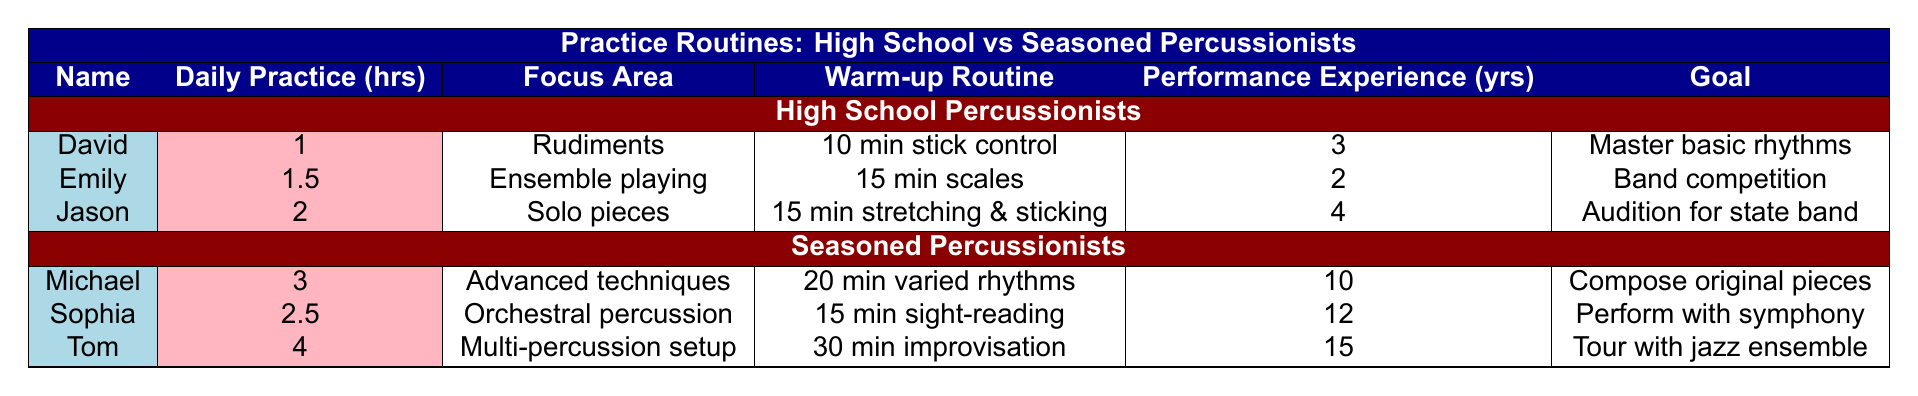What is the maximum number of daily practice hours among high school percussionists? The table shows three high school percussionists: David (1 hr), Emily (1.5 hrs), and Jason (2 hrs). The maximum value among these is Jason's 2 hrs.
Answer: 2 hrs Which seasoned percussionist has the highest performance experience? From the table, we see that Tom has 15 years of performance experience, which is greater than Michael's 10 and Sophia's 12 years.
Answer: Tom What is the warm-up routine for Jason? According to the table, Jason's warm-up routine consists of "5 minutes of stretching, 10 minutes of basic sticking patterns."
Answer: 5 minutes of stretching, 10 minutes of basic sticking patterns How many more hours do seasoned percussionists practice daily on average compared to high school percussionists? High school percussionists have practice hours of 1, 1.5, and 2, which totals 4.5 hours divided by 3 gives an average of 1.5 hours. Seasoned percussionists have 3, 2.5, and 4, totaling 9.5 hours, which gives an average of about 3.17 hours. The difference is 3.17 - 1.5 = 1.67 hours.
Answer: 1.67 hours Is it true that David's goal is to audition for the state band? The table states that David's goal is "master basic rhythms," not auditioning for the state band.
Answer: No Which focus area is unique to seasoned percussionists compared to high school percussionists? The table lists "advanced techniques," "orchestral percussion," and "multi-percussion setup" as focus areas for seasoned percussionists, while high school percussionists focus on "rudiments," "ensemble playing," and "solo pieces." "Advanced techniques" is not listed for high school percussionists.
Answer: Advanced techniques What is the total number of years of performance experience for all high school percussionists combined? The performance experience for high school percussionists is 3 years (David) + 2 years (Emily) + 4 years (Jason) = 9 years total.
Answer: 9 years Who practices less, Sophia or Jason? Sophia practices for 2.5 hours, while Jason practices for 2 hours. Since 2.5 hours is greater than 2 hours, Jason practices less than Sophia.
Answer: Jason 